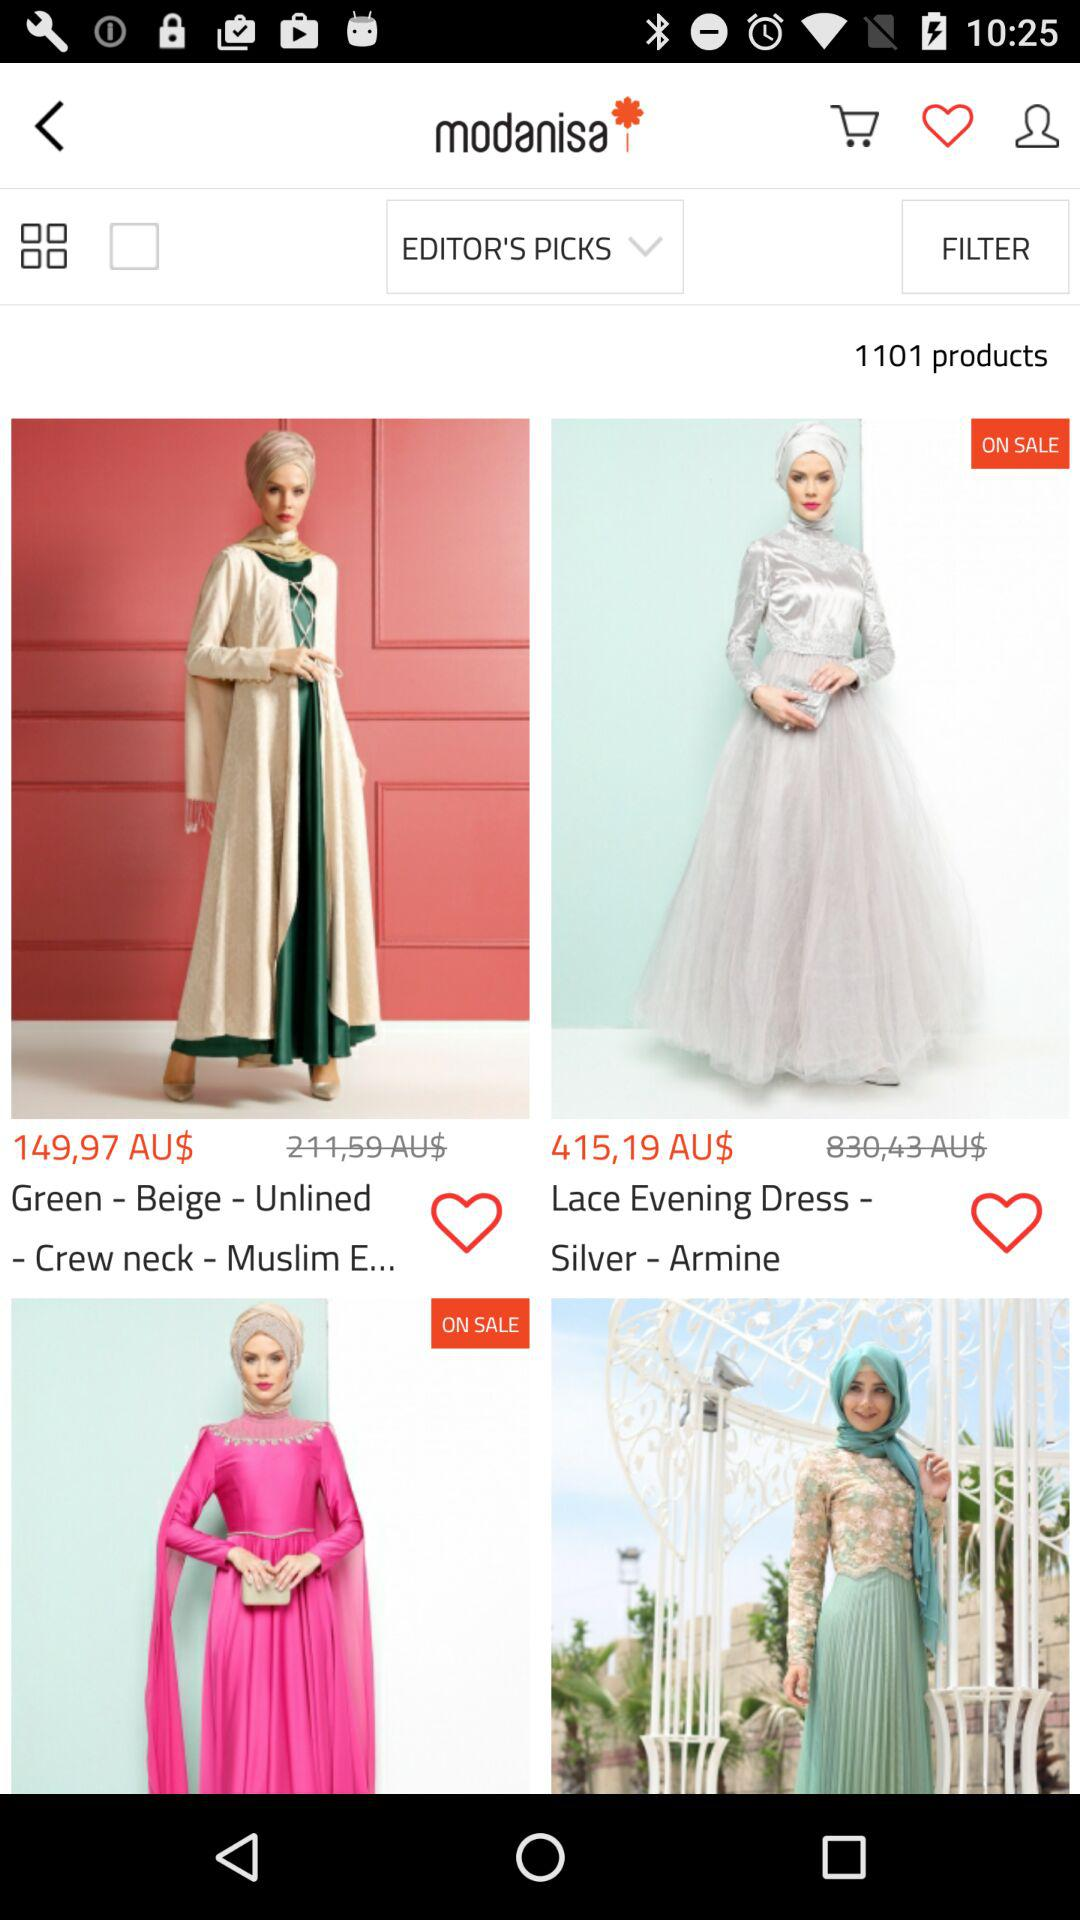What is the price of the "Green - Beige - Unlined"? The price is 149,97 Australian dollars. 